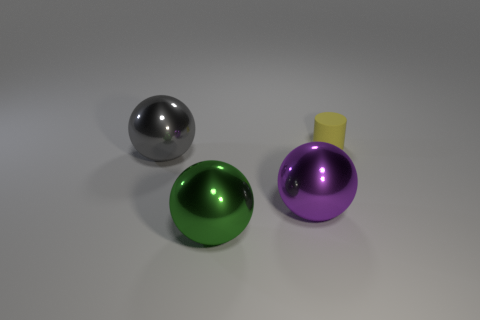There is an object that is behind the large metallic thing left of the green metal object; what size is it? The object behind the large metallic sphere on the left side, which is positioned to the left of the green sphere, appears to be a smaller sphere with a purple hue, capped by what seems to be a flat yellow disk. 